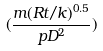<formula> <loc_0><loc_0><loc_500><loc_500>( \frac { m ( R t / k ) ^ { 0 . 5 } } { p D ^ { 2 } } )</formula> 